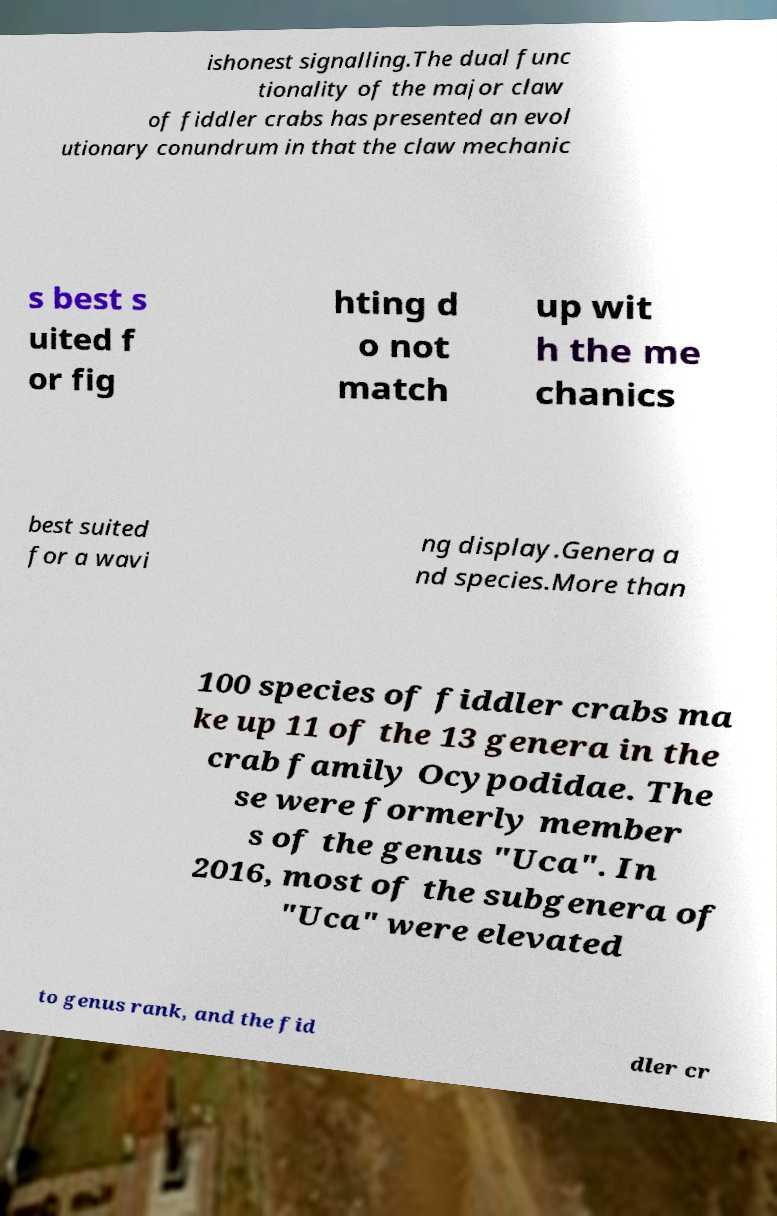What messages or text are displayed in this image? I need them in a readable, typed format. ishonest signalling.The dual func tionality of the major claw of fiddler crabs has presented an evol utionary conundrum in that the claw mechanic s best s uited f or fig hting d o not match up wit h the me chanics best suited for a wavi ng display.Genera a nd species.More than 100 species of fiddler crabs ma ke up 11 of the 13 genera in the crab family Ocypodidae. The se were formerly member s of the genus "Uca". In 2016, most of the subgenera of "Uca" were elevated to genus rank, and the fid dler cr 